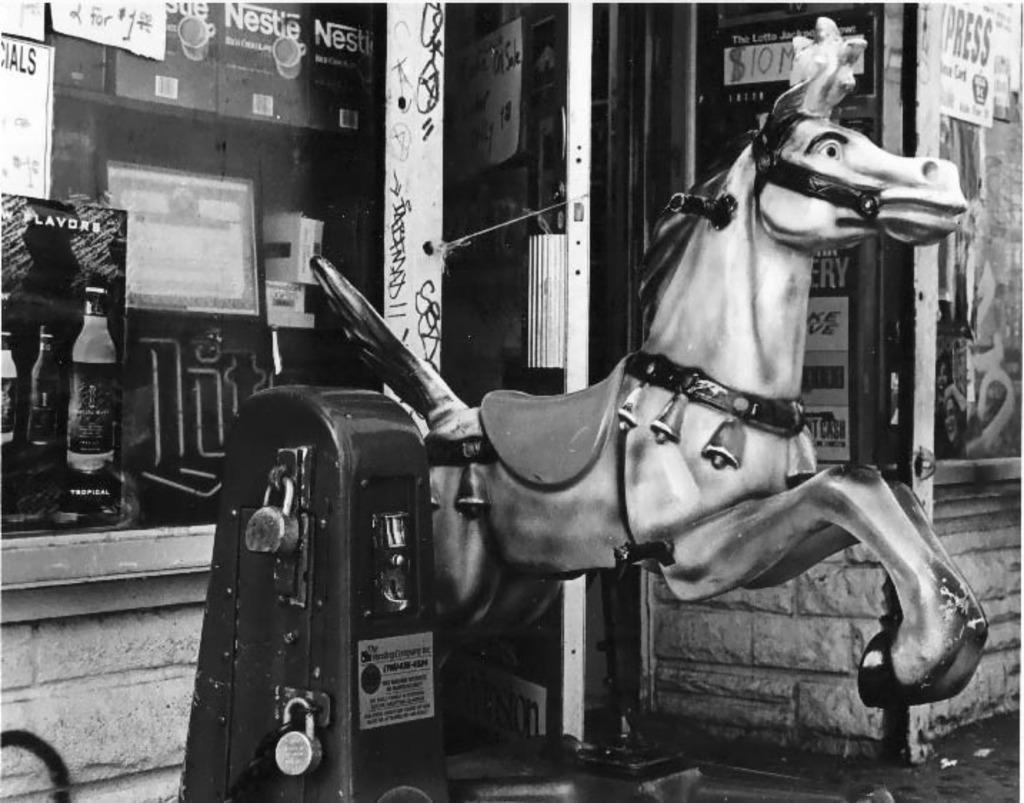Could you give a brief overview of what you see in this image? In this image in the front there is an object which is black in colour and there is a statue of the horse. In the background there are boards with some text written on it and there is a wall. 